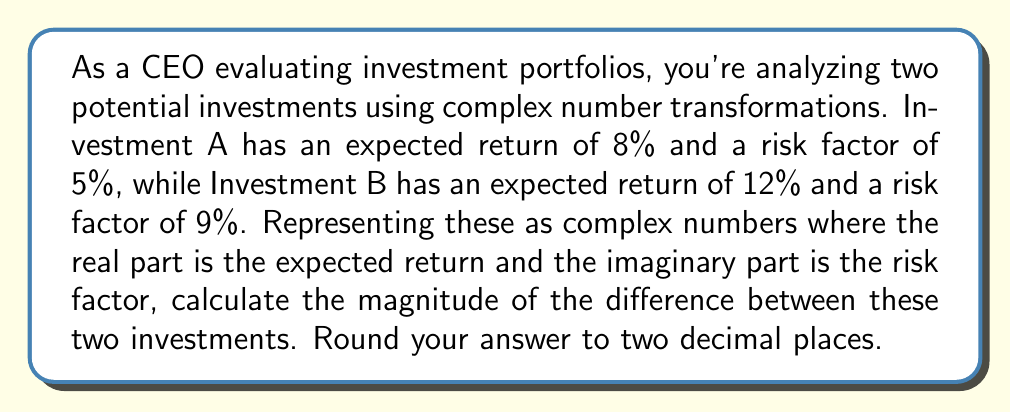Teach me how to tackle this problem. Let's approach this step-by-step:

1) First, we represent each investment as a complex number:
   Investment A: $z_A = 8 + 5i$
   Investment B: $z_B = 12 + 9i$

2) To find the difference between these investments, we subtract:
   $z_B - z_A = (12 + 9i) - (8 + 5i) = (12 - 8) + (9 - 5)i = 4 + 4i$

3) Now, we need to calculate the magnitude of this difference. The magnitude of a complex number $a + bi$ is given by $\sqrt{a^2 + b^2}$.

4) In this case, we have $4 + 4i$, so:
   $|4 + 4i| = \sqrt{4^2 + 4^2} = \sqrt{16 + 16} = \sqrt{32}$

5) Simplify:
   $\sqrt{32} = 4\sqrt{2} \approx 5.66$

6) Rounding to two decimal places:
   $5.66$

This magnitude represents the overall difference between the two investments, considering both return and risk.
Answer: $5.66$ 